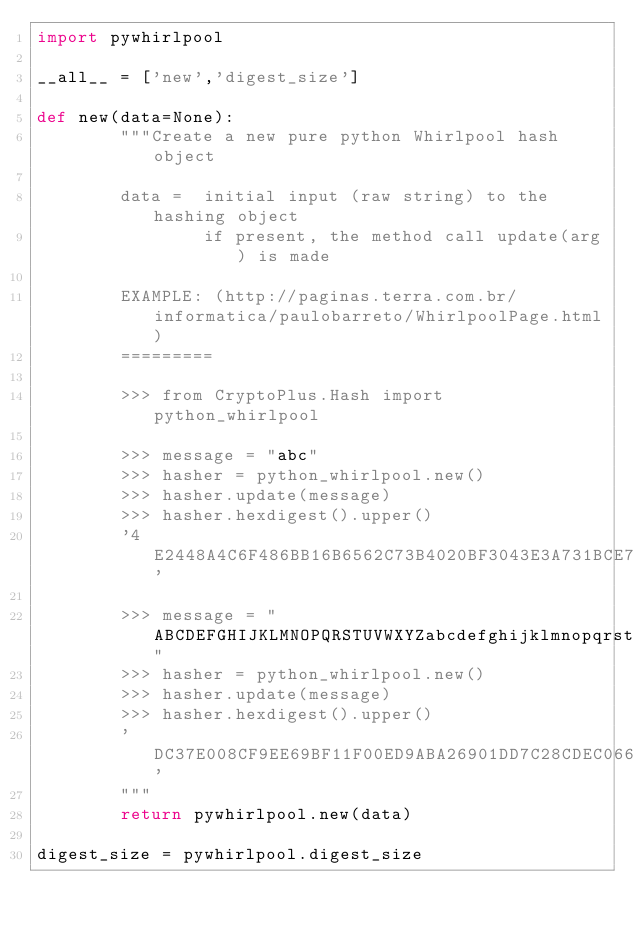<code> <loc_0><loc_0><loc_500><loc_500><_Python_>import pywhirlpool

__all__ = ['new','digest_size']

def new(data=None):
        """Create a new pure python Whirlpool hash object
        
        data =  initial input (raw string) to the hashing object
                if present, the method call update(arg) is made
        
        EXAMPLE: (http://paginas.terra.com.br/informatica/paulobarreto/WhirlpoolPage.html)
        =========
        
        >>> from CryptoPlus.Hash import python_whirlpool
        
        >>> message = "abc"
        >>> hasher = python_whirlpool.new()
        >>> hasher.update(message)
        >>> hasher.hexdigest().upper()
        '4E2448A4C6F486BB16B6562C73B4020BF3043E3A731BCE721AE1B303D97E6D4C7181EEBDB6C57E277D0E34957114CBD6C797FC9D95D8B582D225292076D4EEF5'
        
        >>> message = "ABCDEFGHIJKLMNOPQRSTUVWXYZabcdefghijklmnopqrstuvwxyz0123456789"
        >>> hasher = python_whirlpool.new()
        >>> hasher.update(message)
        >>> hasher.hexdigest().upper()
        'DC37E008CF9EE69BF11F00ED9ABA26901DD7C28CDEC066CC6AF42E40F82F3A1E08EBA26629129D8FB7CB57211B9281A65517CC879D7B962142C65F5A7AF01467'
        """
        return pywhirlpool.new(data)
        
digest_size = pywhirlpool.digest_size
</code> 